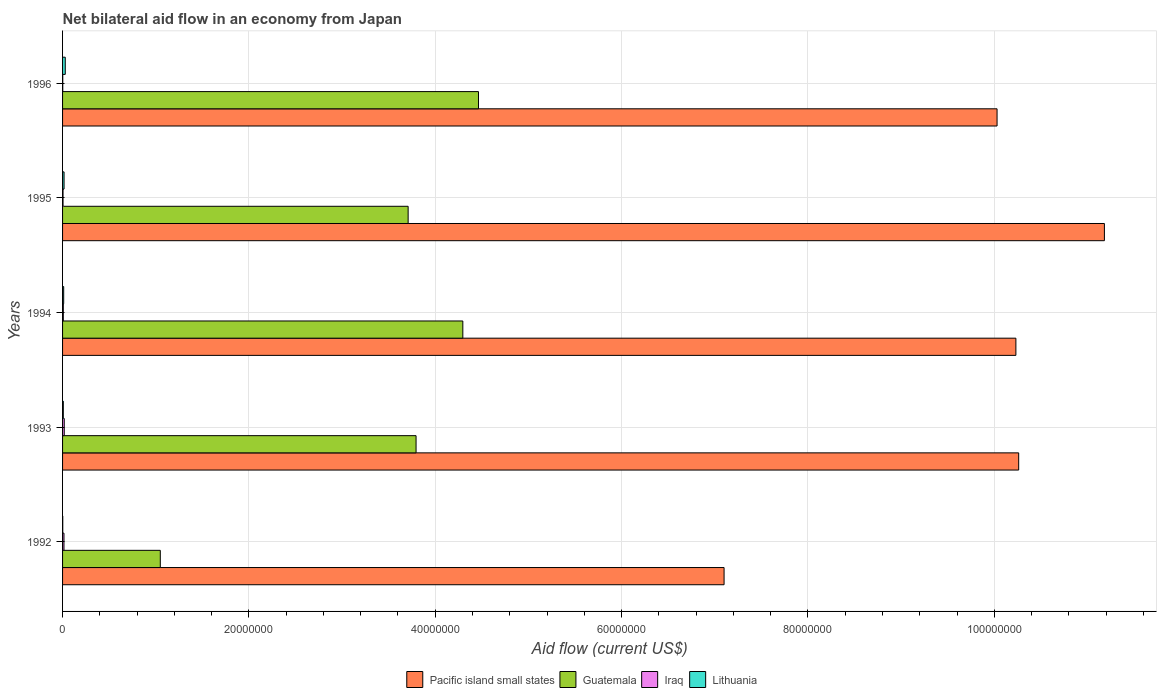How many groups of bars are there?
Provide a short and direct response. 5. How many bars are there on the 3rd tick from the bottom?
Your answer should be very brief. 4. In how many cases, is the number of bars for a given year not equal to the number of legend labels?
Ensure brevity in your answer.  0. What is the net bilateral aid flow in Pacific island small states in 1996?
Provide a short and direct response. 1.00e+08. Across all years, what is the minimum net bilateral aid flow in Pacific island small states?
Give a very brief answer. 7.10e+07. What is the total net bilateral aid flow in Pacific island small states in the graph?
Your answer should be very brief. 4.88e+08. What is the difference between the net bilateral aid flow in Guatemala in 1994 and that in 1996?
Make the answer very short. -1.68e+06. What is the difference between the net bilateral aid flow in Pacific island small states in 1993 and the net bilateral aid flow in Lithuania in 1995?
Your answer should be very brief. 1.02e+08. What is the average net bilateral aid flow in Pacific island small states per year?
Provide a succinct answer. 9.76e+07. In the year 1993, what is the difference between the net bilateral aid flow in Pacific island small states and net bilateral aid flow in Guatemala?
Keep it short and to the point. 6.47e+07. What is the ratio of the net bilateral aid flow in Pacific island small states in 1992 to that in 1996?
Ensure brevity in your answer.  0.71. Is the difference between the net bilateral aid flow in Pacific island small states in 1995 and 1996 greater than the difference between the net bilateral aid flow in Guatemala in 1995 and 1996?
Your answer should be compact. Yes. What is the difference between the highest and the second highest net bilateral aid flow in Pacific island small states?
Provide a succinct answer. 9.20e+06. What is the difference between the highest and the lowest net bilateral aid flow in Pacific island small states?
Give a very brief answer. 4.08e+07. Is it the case that in every year, the sum of the net bilateral aid flow in Lithuania and net bilateral aid flow in Pacific island small states is greater than the sum of net bilateral aid flow in Guatemala and net bilateral aid flow in Iraq?
Keep it short and to the point. No. What does the 3rd bar from the top in 1994 represents?
Your answer should be very brief. Guatemala. What does the 1st bar from the bottom in 1992 represents?
Keep it short and to the point. Pacific island small states. Is it the case that in every year, the sum of the net bilateral aid flow in Pacific island small states and net bilateral aid flow in Lithuania is greater than the net bilateral aid flow in Guatemala?
Keep it short and to the point. Yes. How many bars are there?
Your response must be concise. 20. Are all the bars in the graph horizontal?
Keep it short and to the point. Yes. How many years are there in the graph?
Offer a terse response. 5. What is the difference between two consecutive major ticks on the X-axis?
Your answer should be compact. 2.00e+07. Are the values on the major ticks of X-axis written in scientific E-notation?
Offer a terse response. No. Does the graph contain any zero values?
Offer a very short reply. No. Does the graph contain grids?
Give a very brief answer. Yes. How many legend labels are there?
Your answer should be very brief. 4. How are the legend labels stacked?
Provide a short and direct response. Horizontal. What is the title of the graph?
Make the answer very short. Net bilateral aid flow in an economy from Japan. Does "Romania" appear as one of the legend labels in the graph?
Your answer should be very brief. No. What is the label or title of the X-axis?
Offer a very short reply. Aid flow (current US$). What is the Aid flow (current US$) of Pacific island small states in 1992?
Your response must be concise. 7.10e+07. What is the Aid flow (current US$) of Guatemala in 1992?
Provide a succinct answer. 1.05e+07. What is the Aid flow (current US$) in Lithuania in 1992?
Offer a very short reply. 2.00e+04. What is the Aid flow (current US$) of Pacific island small states in 1993?
Provide a succinct answer. 1.03e+08. What is the Aid flow (current US$) in Guatemala in 1993?
Offer a very short reply. 3.79e+07. What is the Aid flow (current US$) in Iraq in 1993?
Give a very brief answer. 1.80e+05. What is the Aid flow (current US$) in Pacific island small states in 1994?
Your answer should be very brief. 1.02e+08. What is the Aid flow (current US$) in Guatemala in 1994?
Provide a succinct answer. 4.30e+07. What is the Aid flow (current US$) of Lithuania in 1994?
Keep it short and to the point. 1.20e+05. What is the Aid flow (current US$) in Pacific island small states in 1995?
Make the answer very short. 1.12e+08. What is the Aid flow (current US$) in Guatemala in 1995?
Make the answer very short. 3.71e+07. What is the Aid flow (current US$) of Iraq in 1995?
Ensure brevity in your answer.  5.00e+04. What is the Aid flow (current US$) of Lithuania in 1995?
Your answer should be compact. 1.60e+05. What is the Aid flow (current US$) of Pacific island small states in 1996?
Offer a very short reply. 1.00e+08. What is the Aid flow (current US$) of Guatemala in 1996?
Your response must be concise. 4.46e+07. What is the Aid flow (current US$) of Iraq in 1996?
Offer a terse response. 2.00e+04. What is the Aid flow (current US$) of Lithuania in 1996?
Ensure brevity in your answer.  2.90e+05. Across all years, what is the maximum Aid flow (current US$) in Pacific island small states?
Keep it short and to the point. 1.12e+08. Across all years, what is the maximum Aid flow (current US$) in Guatemala?
Ensure brevity in your answer.  4.46e+07. Across all years, what is the minimum Aid flow (current US$) of Pacific island small states?
Your response must be concise. 7.10e+07. Across all years, what is the minimum Aid flow (current US$) in Guatemala?
Ensure brevity in your answer.  1.05e+07. Across all years, what is the minimum Aid flow (current US$) of Lithuania?
Keep it short and to the point. 2.00e+04. What is the total Aid flow (current US$) of Pacific island small states in the graph?
Your answer should be compact. 4.88e+08. What is the total Aid flow (current US$) in Guatemala in the graph?
Offer a very short reply. 1.73e+08. What is the total Aid flow (current US$) of Iraq in the graph?
Offer a terse response. 4.80e+05. What is the total Aid flow (current US$) in Lithuania in the graph?
Offer a very short reply. 6.70e+05. What is the difference between the Aid flow (current US$) in Pacific island small states in 1992 and that in 1993?
Provide a succinct answer. -3.16e+07. What is the difference between the Aid flow (current US$) in Guatemala in 1992 and that in 1993?
Make the answer very short. -2.74e+07. What is the difference between the Aid flow (current US$) in Lithuania in 1992 and that in 1993?
Provide a succinct answer. -6.00e+04. What is the difference between the Aid flow (current US$) in Pacific island small states in 1992 and that in 1994?
Provide a short and direct response. -3.13e+07. What is the difference between the Aid flow (current US$) of Guatemala in 1992 and that in 1994?
Ensure brevity in your answer.  -3.25e+07. What is the difference between the Aid flow (current US$) of Iraq in 1992 and that in 1994?
Offer a very short reply. 7.00e+04. What is the difference between the Aid flow (current US$) in Lithuania in 1992 and that in 1994?
Make the answer very short. -1.00e+05. What is the difference between the Aid flow (current US$) in Pacific island small states in 1992 and that in 1995?
Your answer should be very brief. -4.08e+07. What is the difference between the Aid flow (current US$) in Guatemala in 1992 and that in 1995?
Your answer should be very brief. -2.66e+07. What is the difference between the Aid flow (current US$) of Iraq in 1992 and that in 1995?
Offer a very short reply. 1.00e+05. What is the difference between the Aid flow (current US$) of Pacific island small states in 1992 and that in 1996?
Your answer should be very brief. -2.93e+07. What is the difference between the Aid flow (current US$) in Guatemala in 1992 and that in 1996?
Your answer should be compact. -3.42e+07. What is the difference between the Aid flow (current US$) of Pacific island small states in 1993 and that in 1994?
Provide a succinct answer. 3.00e+05. What is the difference between the Aid flow (current US$) in Guatemala in 1993 and that in 1994?
Offer a very short reply. -5.02e+06. What is the difference between the Aid flow (current US$) of Iraq in 1993 and that in 1994?
Ensure brevity in your answer.  1.00e+05. What is the difference between the Aid flow (current US$) in Pacific island small states in 1993 and that in 1995?
Provide a succinct answer. -9.20e+06. What is the difference between the Aid flow (current US$) in Guatemala in 1993 and that in 1995?
Provide a succinct answer. 8.50e+05. What is the difference between the Aid flow (current US$) of Iraq in 1993 and that in 1995?
Provide a succinct answer. 1.30e+05. What is the difference between the Aid flow (current US$) of Lithuania in 1993 and that in 1995?
Your response must be concise. -8.00e+04. What is the difference between the Aid flow (current US$) in Pacific island small states in 1993 and that in 1996?
Keep it short and to the point. 2.32e+06. What is the difference between the Aid flow (current US$) of Guatemala in 1993 and that in 1996?
Offer a very short reply. -6.70e+06. What is the difference between the Aid flow (current US$) in Lithuania in 1993 and that in 1996?
Offer a very short reply. -2.10e+05. What is the difference between the Aid flow (current US$) in Pacific island small states in 1994 and that in 1995?
Give a very brief answer. -9.50e+06. What is the difference between the Aid flow (current US$) in Guatemala in 1994 and that in 1995?
Ensure brevity in your answer.  5.87e+06. What is the difference between the Aid flow (current US$) of Iraq in 1994 and that in 1995?
Offer a very short reply. 3.00e+04. What is the difference between the Aid flow (current US$) of Pacific island small states in 1994 and that in 1996?
Your answer should be compact. 2.02e+06. What is the difference between the Aid flow (current US$) in Guatemala in 1994 and that in 1996?
Make the answer very short. -1.68e+06. What is the difference between the Aid flow (current US$) in Pacific island small states in 1995 and that in 1996?
Your answer should be compact. 1.15e+07. What is the difference between the Aid flow (current US$) in Guatemala in 1995 and that in 1996?
Provide a succinct answer. -7.55e+06. What is the difference between the Aid flow (current US$) in Lithuania in 1995 and that in 1996?
Offer a very short reply. -1.30e+05. What is the difference between the Aid flow (current US$) of Pacific island small states in 1992 and the Aid flow (current US$) of Guatemala in 1993?
Offer a terse response. 3.31e+07. What is the difference between the Aid flow (current US$) of Pacific island small states in 1992 and the Aid flow (current US$) of Iraq in 1993?
Provide a short and direct response. 7.08e+07. What is the difference between the Aid flow (current US$) in Pacific island small states in 1992 and the Aid flow (current US$) in Lithuania in 1993?
Give a very brief answer. 7.09e+07. What is the difference between the Aid flow (current US$) of Guatemala in 1992 and the Aid flow (current US$) of Iraq in 1993?
Give a very brief answer. 1.03e+07. What is the difference between the Aid flow (current US$) of Guatemala in 1992 and the Aid flow (current US$) of Lithuania in 1993?
Offer a very short reply. 1.04e+07. What is the difference between the Aid flow (current US$) in Pacific island small states in 1992 and the Aid flow (current US$) in Guatemala in 1994?
Offer a terse response. 2.80e+07. What is the difference between the Aid flow (current US$) in Pacific island small states in 1992 and the Aid flow (current US$) in Iraq in 1994?
Your answer should be very brief. 7.09e+07. What is the difference between the Aid flow (current US$) of Pacific island small states in 1992 and the Aid flow (current US$) of Lithuania in 1994?
Ensure brevity in your answer.  7.09e+07. What is the difference between the Aid flow (current US$) of Guatemala in 1992 and the Aid flow (current US$) of Iraq in 1994?
Offer a very short reply. 1.04e+07. What is the difference between the Aid flow (current US$) in Guatemala in 1992 and the Aid flow (current US$) in Lithuania in 1994?
Keep it short and to the point. 1.04e+07. What is the difference between the Aid flow (current US$) of Pacific island small states in 1992 and the Aid flow (current US$) of Guatemala in 1995?
Make the answer very short. 3.39e+07. What is the difference between the Aid flow (current US$) of Pacific island small states in 1992 and the Aid flow (current US$) of Iraq in 1995?
Your answer should be compact. 7.10e+07. What is the difference between the Aid flow (current US$) of Pacific island small states in 1992 and the Aid flow (current US$) of Lithuania in 1995?
Your answer should be very brief. 7.08e+07. What is the difference between the Aid flow (current US$) of Guatemala in 1992 and the Aid flow (current US$) of Iraq in 1995?
Make the answer very short. 1.04e+07. What is the difference between the Aid flow (current US$) in Guatemala in 1992 and the Aid flow (current US$) in Lithuania in 1995?
Your answer should be compact. 1.03e+07. What is the difference between the Aid flow (current US$) in Pacific island small states in 1992 and the Aid flow (current US$) in Guatemala in 1996?
Your answer should be very brief. 2.64e+07. What is the difference between the Aid flow (current US$) of Pacific island small states in 1992 and the Aid flow (current US$) of Iraq in 1996?
Give a very brief answer. 7.10e+07. What is the difference between the Aid flow (current US$) in Pacific island small states in 1992 and the Aid flow (current US$) in Lithuania in 1996?
Your answer should be compact. 7.07e+07. What is the difference between the Aid flow (current US$) in Guatemala in 1992 and the Aid flow (current US$) in Iraq in 1996?
Provide a succinct answer. 1.05e+07. What is the difference between the Aid flow (current US$) in Guatemala in 1992 and the Aid flow (current US$) in Lithuania in 1996?
Provide a succinct answer. 1.02e+07. What is the difference between the Aid flow (current US$) in Iraq in 1992 and the Aid flow (current US$) in Lithuania in 1996?
Your response must be concise. -1.40e+05. What is the difference between the Aid flow (current US$) of Pacific island small states in 1993 and the Aid flow (current US$) of Guatemala in 1994?
Your answer should be compact. 5.97e+07. What is the difference between the Aid flow (current US$) of Pacific island small states in 1993 and the Aid flow (current US$) of Iraq in 1994?
Ensure brevity in your answer.  1.03e+08. What is the difference between the Aid flow (current US$) in Pacific island small states in 1993 and the Aid flow (current US$) in Lithuania in 1994?
Provide a succinct answer. 1.02e+08. What is the difference between the Aid flow (current US$) of Guatemala in 1993 and the Aid flow (current US$) of Iraq in 1994?
Your answer should be very brief. 3.79e+07. What is the difference between the Aid flow (current US$) of Guatemala in 1993 and the Aid flow (current US$) of Lithuania in 1994?
Give a very brief answer. 3.78e+07. What is the difference between the Aid flow (current US$) in Iraq in 1993 and the Aid flow (current US$) in Lithuania in 1994?
Provide a short and direct response. 6.00e+04. What is the difference between the Aid flow (current US$) of Pacific island small states in 1993 and the Aid flow (current US$) of Guatemala in 1995?
Ensure brevity in your answer.  6.55e+07. What is the difference between the Aid flow (current US$) of Pacific island small states in 1993 and the Aid flow (current US$) of Iraq in 1995?
Your response must be concise. 1.03e+08. What is the difference between the Aid flow (current US$) in Pacific island small states in 1993 and the Aid flow (current US$) in Lithuania in 1995?
Ensure brevity in your answer.  1.02e+08. What is the difference between the Aid flow (current US$) of Guatemala in 1993 and the Aid flow (current US$) of Iraq in 1995?
Ensure brevity in your answer.  3.79e+07. What is the difference between the Aid flow (current US$) of Guatemala in 1993 and the Aid flow (current US$) of Lithuania in 1995?
Your response must be concise. 3.78e+07. What is the difference between the Aid flow (current US$) of Iraq in 1993 and the Aid flow (current US$) of Lithuania in 1995?
Provide a short and direct response. 2.00e+04. What is the difference between the Aid flow (current US$) of Pacific island small states in 1993 and the Aid flow (current US$) of Guatemala in 1996?
Give a very brief answer. 5.80e+07. What is the difference between the Aid flow (current US$) in Pacific island small states in 1993 and the Aid flow (current US$) in Iraq in 1996?
Your response must be concise. 1.03e+08. What is the difference between the Aid flow (current US$) in Pacific island small states in 1993 and the Aid flow (current US$) in Lithuania in 1996?
Make the answer very short. 1.02e+08. What is the difference between the Aid flow (current US$) of Guatemala in 1993 and the Aid flow (current US$) of Iraq in 1996?
Provide a short and direct response. 3.79e+07. What is the difference between the Aid flow (current US$) in Guatemala in 1993 and the Aid flow (current US$) in Lithuania in 1996?
Provide a succinct answer. 3.76e+07. What is the difference between the Aid flow (current US$) in Pacific island small states in 1994 and the Aid flow (current US$) in Guatemala in 1995?
Offer a terse response. 6.52e+07. What is the difference between the Aid flow (current US$) of Pacific island small states in 1994 and the Aid flow (current US$) of Iraq in 1995?
Give a very brief answer. 1.02e+08. What is the difference between the Aid flow (current US$) of Pacific island small states in 1994 and the Aid flow (current US$) of Lithuania in 1995?
Provide a short and direct response. 1.02e+08. What is the difference between the Aid flow (current US$) in Guatemala in 1994 and the Aid flow (current US$) in Iraq in 1995?
Offer a very short reply. 4.29e+07. What is the difference between the Aid flow (current US$) in Guatemala in 1994 and the Aid flow (current US$) in Lithuania in 1995?
Offer a very short reply. 4.28e+07. What is the difference between the Aid flow (current US$) of Pacific island small states in 1994 and the Aid flow (current US$) of Guatemala in 1996?
Provide a short and direct response. 5.77e+07. What is the difference between the Aid flow (current US$) of Pacific island small states in 1994 and the Aid flow (current US$) of Iraq in 1996?
Offer a very short reply. 1.02e+08. What is the difference between the Aid flow (current US$) of Pacific island small states in 1994 and the Aid flow (current US$) of Lithuania in 1996?
Ensure brevity in your answer.  1.02e+08. What is the difference between the Aid flow (current US$) of Guatemala in 1994 and the Aid flow (current US$) of Iraq in 1996?
Offer a very short reply. 4.29e+07. What is the difference between the Aid flow (current US$) in Guatemala in 1994 and the Aid flow (current US$) in Lithuania in 1996?
Offer a very short reply. 4.27e+07. What is the difference between the Aid flow (current US$) of Iraq in 1994 and the Aid flow (current US$) of Lithuania in 1996?
Make the answer very short. -2.10e+05. What is the difference between the Aid flow (current US$) in Pacific island small states in 1995 and the Aid flow (current US$) in Guatemala in 1996?
Your answer should be very brief. 6.72e+07. What is the difference between the Aid flow (current US$) of Pacific island small states in 1995 and the Aid flow (current US$) of Iraq in 1996?
Provide a succinct answer. 1.12e+08. What is the difference between the Aid flow (current US$) of Pacific island small states in 1995 and the Aid flow (current US$) of Lithuania in 1996?
Your answer should be compact. 1.12e+08. What is the difference between the Aid flow (current US$) in Guatemala in 1995 and the Aid flow (current US$) in Iraq in 1996?
Keep it short and to the point. 3.71e+07. What is the difference between the Aid flow (current US$) in Guatemala in 1995 and the Aid flow (current US$) in Lithuania in 1996?
Give a very brief answer. 3.68e+07. What is the difference between the Aid flow (current US$) of Iraq in 1995 and the Aid flow (current US$) of Lithuania in 1996?
Your answer should be compact. -2.40e+05. What is the average Aid flow (current US$) in Pacific island small states per year?
Provide a succinct answer. 9.76e+07. What is the average Aid flow (current US$) in Guatemala per year?
Ensure brevity in your answer.  3.46e+07. What is the average Aid flow (current US$) of Iraq per year?
Offer a very short reply. 9.60e+04. What is the average Aid flow (current US$) in Lithuania per year?
Provide a succinct answer. 1.34e+05. In the year 1992, what is the difference between the Aid flow (current US$) in Pacific island small states and Aid flow (current US$) in Guatemala?
Your answer should be compact. 6.05e+07. In the year 1992, what is the difference between the Aid flow (current US$) of Pacific island small states and Aid flow (current US$) of Iraq?
Your answer should be very brief. 7.08e+07. In the year 1992, what is the difference between the Aid flow (current US$) of Pacific island small states and Aid flow (current US$) of Lithuania?
Provide a short and direct response. 7.10e+07. In the year 1992, what is the difference between the Aid flow (current US$) in Guatemala and Aid flow (current US$) in Iraq?
Your answer should be compact. 1.03e+07. In the year 1992, what is the difference between the Aid flow (current US$) in Guatemala and Aid flow (current US$) in Lithuania?
Provide a short and direct response. 1.05e+07. In the year 1993, what is the difference between the Aid flow (current US$) in Pacific island small states and Aid flow (current US$) in Guatemala?
Keep it short and to the point. 6.47e+07. In the year 1993, what is the difference between the Aid flow (current US$) in Pacific island small states and Aid flow (current US$) in Iraq?
Offer a terse response. 1.02e+08. In the year 1993, what is the difference between the Aid flow (current US$) in Pacific island small states and Aid flow (current US$) in Lithuania?
Provide a succinct answer. 1.03e+08. In the year 1993, what is the difference between the Aid flow (current US$) of Guatemala and Aid flow (current US$) of Iraq?
Your answer should be compact. 3.78e+07. In the year 1993, what is the difference between the Aid flow (current US$) of Guatemala and Aid flow (current US$) of Lithuania?
Offer a very short reply. 3.79e+07. In the year 1993, what is the difference between the Aid flow (current US$) of Iraq and Aid flow (current US$) of Lithuania?
Offer a very short reply. 1.00e+05. In the year 1994, what is the difference between the Aid flow (current US$) of Pacific island small states and Aid flow (current US$) of Guatemala?
Your answer should be very brief. 5.94e+07. In the year 1994, what is the difference between the Aid flow (current US$) of Pacific island small states and Aid flow (current US$) of Iraq?
Provide a short and direct response. 1.02e+08. In the year 1994, what is the difference between the Aid flow (current US$) in Pacific island small states and Aid flow (current US$) in Lithuania?
Ensure brevity in your answer.  1.02e+08. In the year 1994, what is the difference between the Aid flow (current US$) of Guatemala and Aid flow (current US$) of Iraq?
Your answer should be very brief. 4.29e+07. In the year 1994, what is the difference between the Aid flow (current US$) in Guatemala and Aid flow (current US$) in Lithuania?
Ensure brevity in your answer.  4.28e+07. In the year 1994, what is the difference between the Aid flow (current US$) of Iraq and Aid flow (current US$) of Lithuania?
Make the answer very short. -4.00e+04. In the year 1995, what is the difference between the Aid flow (current US$) in Pacific island small states and Aid flow (current US$) in Guatemala?
Ensure brevity in your answer.  7.47e+07. In the year 1995, what is the difference between the Aid flow (current US$) of Pacific island small states and Aid flow (current US$) of Iraq?
Give a very brief answer. 1.12e+08. In the year 1995, what is the difference between the Aid flow (current US$) in Pacific island small states and Aid flow (current US$) in Lithuania?
Give a very brief answer. 1.12e+08. In the year 1995, what is the difference between the Aid flow (current US$) in Guatemala and Aid flow (current US$) in Iraq?
Offer a terse response. 3.70e+07. In the year 1995, what is the difference between the Aid flow (current US$) of Guatemala and Aid flow (current US$) of Lithuania?
Your answer should be compact. 3.69e+07. In the year 1995, what is the difference between the Aid flow (current US$) of Iraq and Aid flow (current US$) of Lithuania?
Keep it short and to the point. -1.10e+05. In the year 1996, what is the difference between the Aid flow (current US$) of Pacific island small states and Aid flow (current US$) of Guatemala?
Make the answer very short. 5.57e+07. In the year 1996, what is the difference between the Aid flow (current US$) in Pacific island small states and Aid flow (current US$) in Iraq?
Ensure brevity in your answer.  1.00e+08. In the year 1996, what is the difference between the Aid flow (current US$) in Pacific island small states and Aid flow (current US$) in Lithuania?
Keep it short and to the point. 1.00e+08. In the year 1996, what is the difference between the Aid flow (current US$) of Guatemala and Aid flow (current US$) of Iraq?
Ensure brevity in your answer.  4.46e+07. In the year 1996, what is the difference between the Aid flow (current US$) in Guatemala and Aid flow (current US$) in Lithuania?
Provide a succinct answer. 4.44e+07. In the year 1996, what is the difference between the Aid flow (current US$) in Iraq and Aid flow (current US$) in Lithuania?
Your answer should be compact. -2.70e+05. What is the ratio of the Aid flow (current US$) in Pacific island small states in 1992 to that in 1993?
Ensure brevity in your answer.  0.69. What is the ratio of the Aid flow (current US$) of Guatemala in 1992 to that in 1993?
Offer a very short reply. 0.28. What is the ratio of the Aid flow (current US$) of Iraq in 1992 to that in 1993?
Make the answer very short. 0.83. What is the ratio of the Aid flow (current US$) of Pacific island small states in 1992 to that in 1994?
Your answer should be compact. 0.69. What is the ratio of the Aid flow (current US$) in Guatemala in 1992 to that in 1994?
Ensure brevity in your answer.  0.24. What is the ratio of the Aid flow (current US$) of Iraq in 1992 to that in 1994?
Provide a succinct answer. 1.88. What is the ratio of the Aid flow (current US$) in Pacific island small states in 1992 to that in 1995?
Offer a very short reply. 0.63. What is the ratio of the Aid flow (current US$) in Guatemala in 1992 to that in 1995?
Offer a very short reply. 0.28. What is the ratio of the Aid flow (current US$) of Iraq in 1992 to that in 1995?
Make the answer very short. 3. What is the ratio of the Aid flow (current US$) of Pacific island small states in 1992 to that in 1996?
Make the answer very short. 0.71. What is the ratio of the Aid flow (current US$) of Guatemala in 1992 to that in 1996?
Keep it short and to the point. 0.23. What is the ratio of the Aid flow (current US$) in Iraq in 1992 to that in 1996?
Offer a very short reply. 7.5. What is the ratio of the Aid flow (current US$) in Lithuania in 1992 to that in 1996?
Give a very brief answer. 0.07. What is the ratio of the Aid flow (current US$) in Guatemala in 1993 to that in 1994?
Ensure brevity in your answer.  0.88. What is the ratio of the Aid flow (current US$) of Iraq in 1993 to that in 1994?
Give a very brief answer. 2.25. What is the ratio of the Aid flow (current US$) of Lithuania in 1993 to that in 1994?
Provide a short and direct response. 0.67. What is the ratio of the Aid flow (current US$) of Pacific island small states in 1993 to that in 1995?
Your response must be concise. 0.92. What is the ratio of the Aid flow (current US$) of Guatemala in 1993 to that in 1995?
Ensure brevity in your answer.  1.02. What is the ratio of the Aid flow (current US$) of Iraq in 1993 to that in 1995?
Ensure brevity in your answer.  3.6. What is the ratio of the Aid flow (current US$) of Pacific island small states in 1993 to that in 1996?
Make the answer very short. 1.02. What is the ratio of the Aid flow (current US$) in Guatemala in 1993 to that in 1996?
Provide a short and direct response. 0.85. What is the ratio of the Aid flow (current US$) of Iraq in 1993 to that in 1996?
Give a very brief answer. 9. What is the ratio of the Aid flow (current US$) in Lithuania in 1993 to that in 1996?
Provide a succinct answer. 0.28. What is the ratio of the Aid flow (current US$) in Pacific island small states in 1994 to that in 1995?
Offer a very short reply. 0.92. What is the ratio of the Aid flow (current US$) in Guatemala in 1994 to that in 1995?
Ensure brevity in your answer.  1.16. What is the ratio of the Aid flow (current US$) in Pacific island small states in 1994 to that in 1996?
Provide a short and direct response. 1.02. What is the ratio of the Aid flow (current US$) of Guatemala in 1994 to that in 1996?
Your answer should be compact. 0.96. What is the ratio of the Aid flow (current US$) of Iraq in 1994 to that in 1996?
Give a very brief answer. 4. What is the ratio of the Aid flow (current US$) of Lithuania in 1994 to that in 1996?
Give a very brief answer. 0.41. What is the ratio of the Aid flow (current US$) in Pacific island small states in 1995 to that in 1996?
Keep it short and to the point. 1.11. What is the ratio of the Aid flow (current US$) of Guatemala in 1995 to that in 1996?
Offer a terse response. 0.83. What is the ratio of the Aid flow (current US$) in Iraq in 1995 to that in 1996?
Offer a terse response. 2.5. What is the ratio of the Aid flow (current US$) of Lithuania in 1995 to that in 1996?
Your response must be concise. 0.55. What is the difference between the highest and the second highest Aid flow (current US$) of Pacific island small states?
Offer a very short reply. 9.20e+06. What is the difference between the highest and the second highest Aid flow (current US$) in Guatemala?
Make the answer very short. 1.68e+06. What is the difference between the highest and the second highest Aid flow (current US$) in Iraq?
Provide a short and direct response. 3.00e+04. What is the difference between the highest and the second highest Aid flow (current US$) of Lithuania?
Your answer should be very brief. 1.30e+05. What is the difference between the highest and the lowest Aid flow (current US$) of Pacific island small states?
Your response must be concise. 4.08e+07. What is the difference between the highest and the lowest Aid flow (current US$) in Guatemala?
Provide a succinct answer. 3.42e+07. What is the difference between the highest and the lowest Aid flow (current US$) of Iraq?
Provide a succinct answer. 1.60e+05. What is the difference between the highest and the lowest Aid flow (current US$) of Lithuania?
Your answer should be compact. 2.70e+05. 